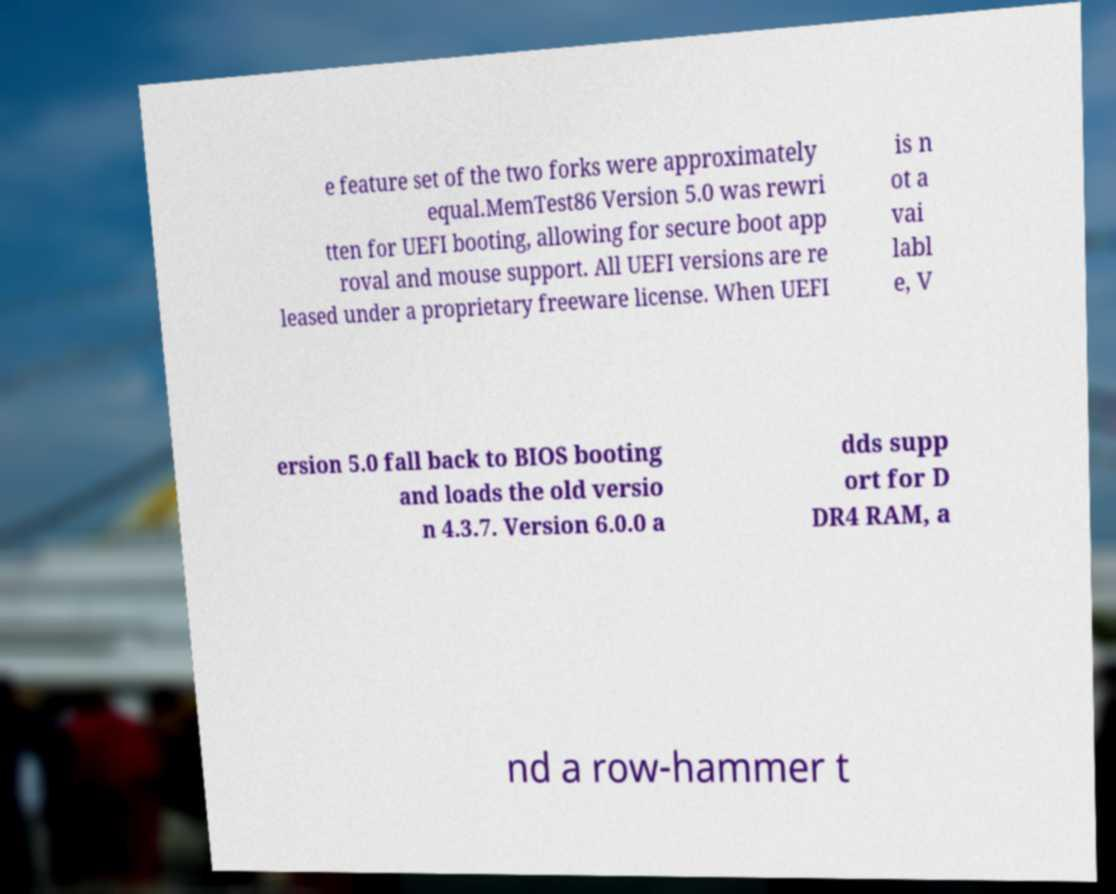Please identify and transcribe the text found in this image. e feature set of the two forks were approximately equal.MemTest86 Version 5.0 was rewri tten for UEFI booting, allowing for secure boot app roval and mouse support. All UEFI versions are re leased under a proprietary freeware license. When UEFI is n ot a vai labl e, V ersion 5.0 fall back to BIOS booting and loads the old versio n 4.3.7. Version 6.0.0 a dds supp ort for D DR4 RAM, a nd a row-hammer t 